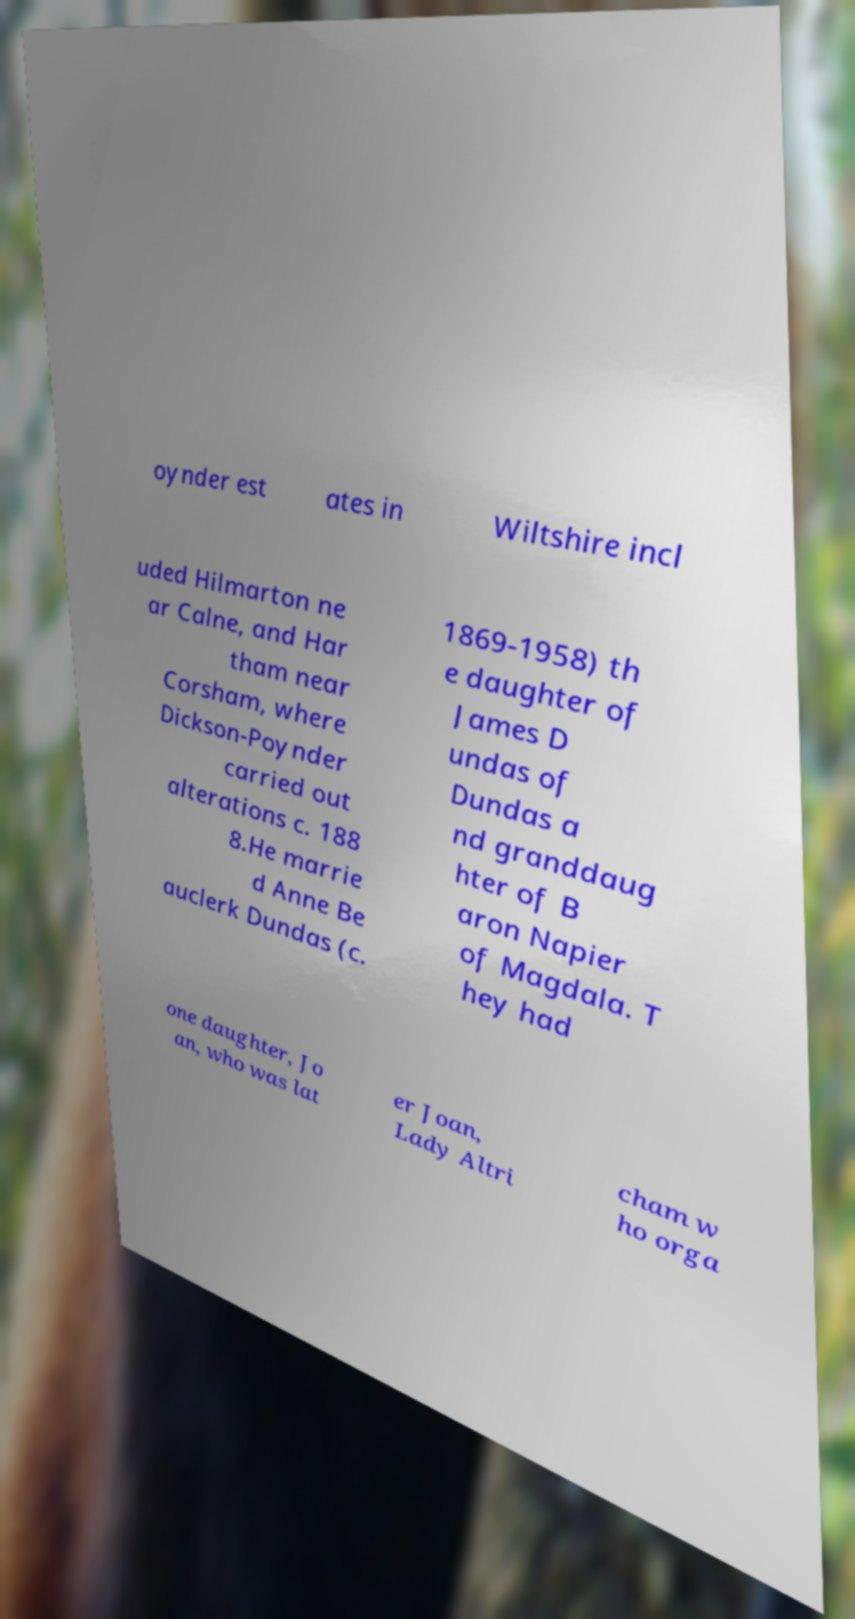Please identify and transcribe the text found in this image. oynder est ates in Wiltshire incl uded Hilmarton ne ar Calne, and Har tham near Corsham, where Dickson-Poynder carried out alterations c. 188 8.He marrie d Anne Be auclerk Dundas (c. 1869-1958) th e daughter of James D undas of Dundas a nd granddaug hter of B aron Napier of Magdala. T hey had one daughter, Jo an, who was lat er Joan, Lady Altri cham w ho orga 